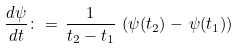Convert formula to latex. <formula><loc_0><loc_0><loc_500><loc_500>\frac { d \psi } { d t } \colon = \, \frac { 1 } { t _ { 2 } - t _ { 1 } } \, \left ( \psi ( t _ { 2 } ) - \, \psi ( t _ { 1 } ) \right )</formula> 